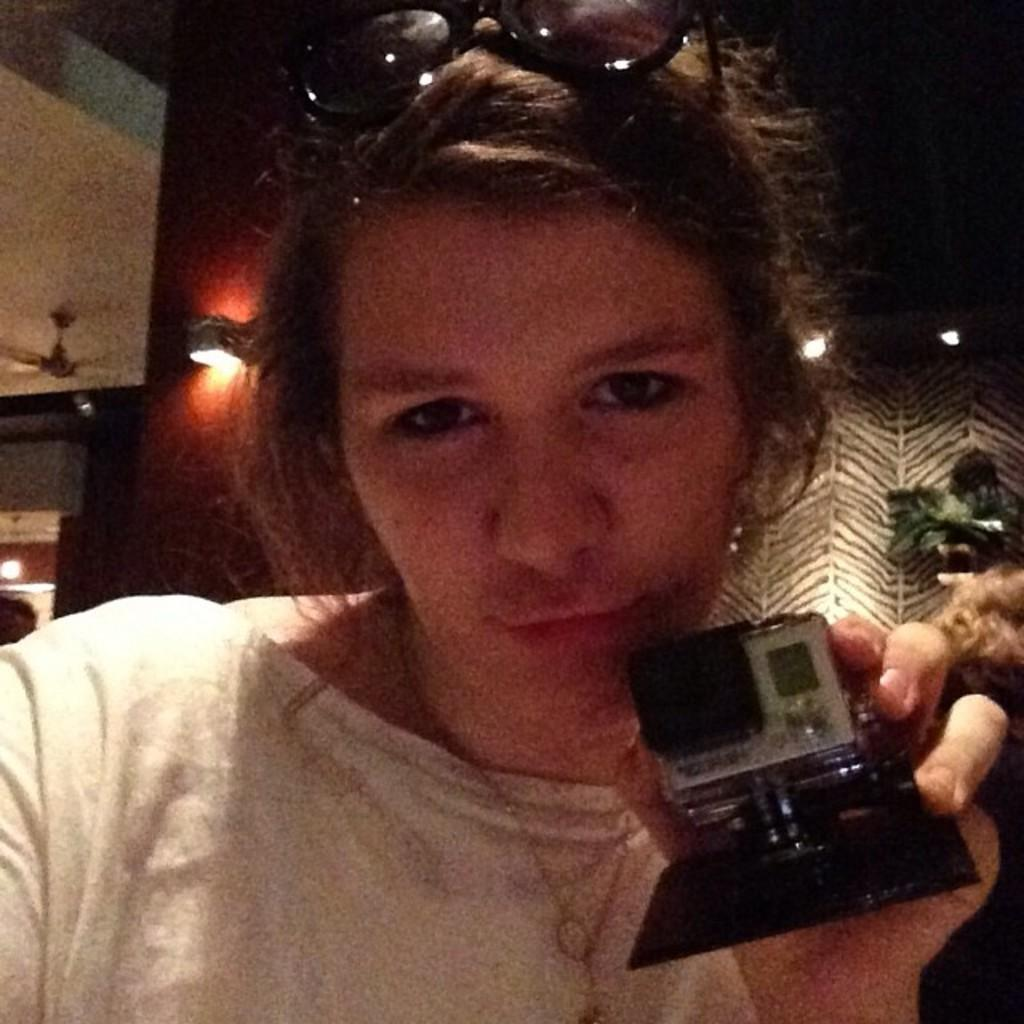Who is present in the image? There is a woman in the image. What is the woman holding in the image? The woman is holding something. What can be seen in the background of the image? There is a fan and lights in the background of the image. What type of treatment is the woman receiving from the maid in the image? There is no maid present in the image, and the woman is not receiving any treatment. 